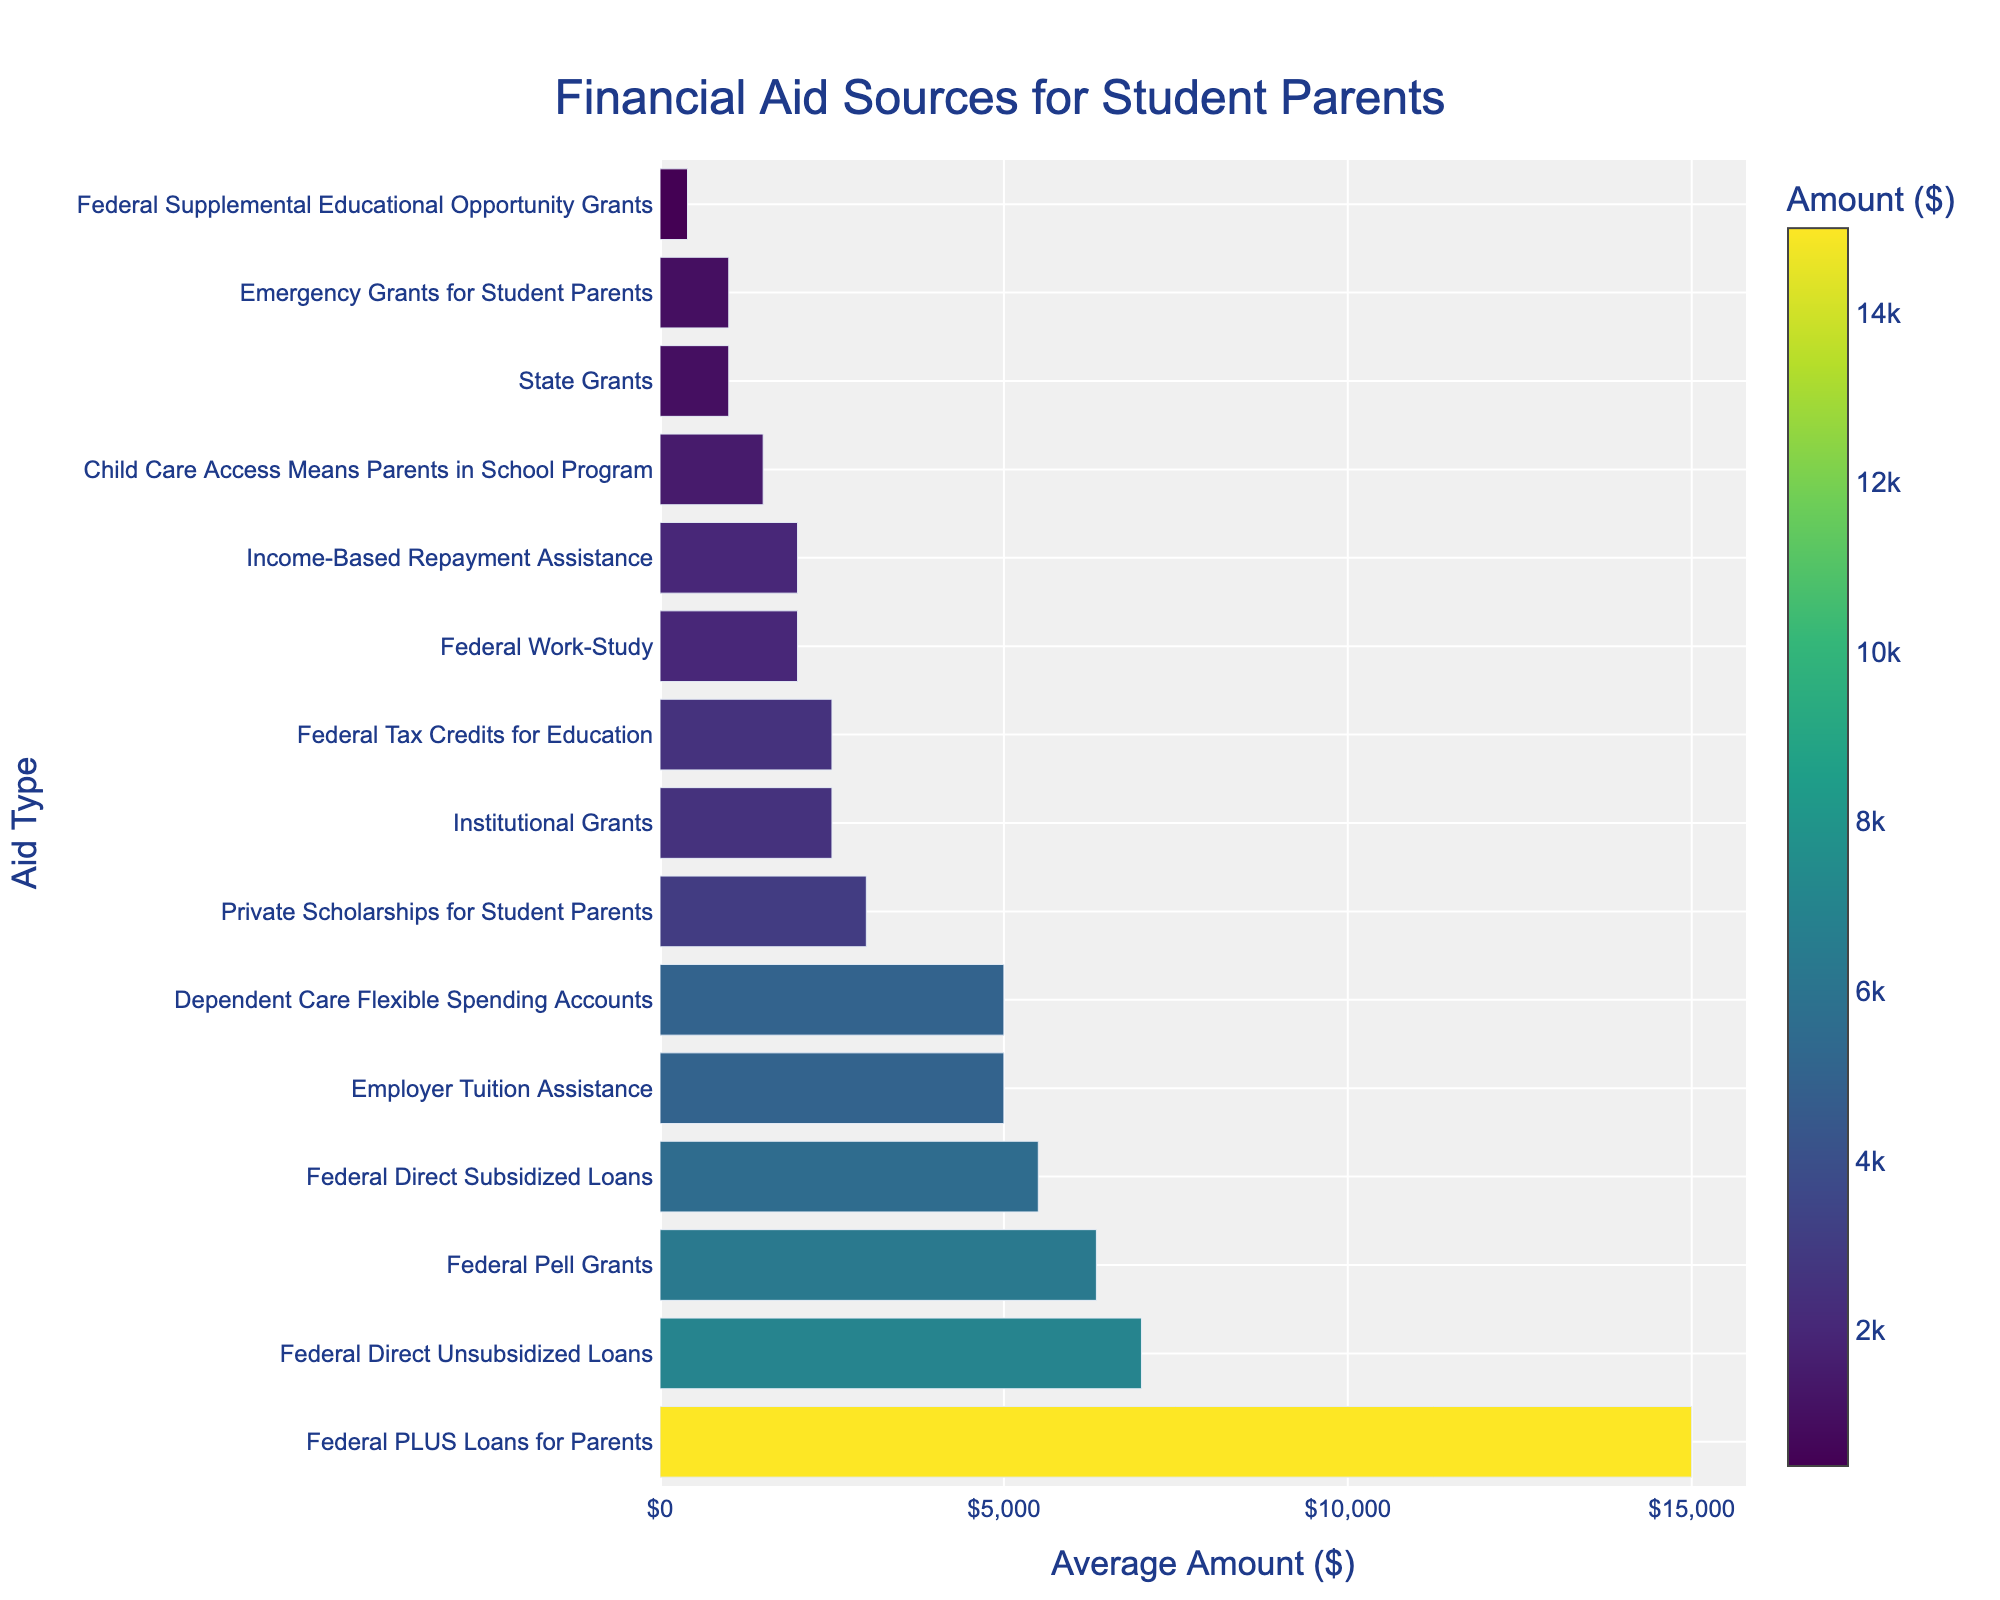What is the highest average amount of financial aid provided for student parents? The bar representing "Federal PLUS Loans for Parents" is the longest, indicating it has the highest average amount of financial aid.
Answer: $15,000 Which financial aid type has the lowest average amount? The bar for "Federal Supplemental Educational Opportunity Grants" is the shortest, indicating it has the lowest average amount.
Answer: $400 How much more on average does "Employer Tuition Assistance" provide compared to "Institutional Grants"? The average amount for "Employer Tuition Assistance" is $5,000 and for "Institutional Grants" is $2,500. The difference is $5,000 - $2,500.
Answer: $2,500 What is the total average amount of federal grants listed? Summing the average amounts for Federal Pell Grants ($6,345) and Federal Supplemental Educational Opportunity Grants ($400) gives $6,345 + $400.
Answer: $6,745 Compare the average amounts between "Federal Work-Study" and "Income-Based Repayment Assistance." Which one is higher and by how much? The average amount for "Federal Work-Study" is $2,000, while for "Income-Based Repayment Assistance" it's also $2,000. They are the same.
Answer: $0 What is the combined average amount of "State Grants" and "Emergency Grants for Student Parents"? The average amount for "State Grants" is $1,000 and for "Emergency Grants for Student Parents" is also $1,000. The combined amount is $1,000 + $1,000.
Answer: $2,000 Which financial aid source is closest in amount to "Private Scholarships for Student Parents"? "Private Scholarships for Student Parents" have an average amount of $3,000. "Federal Work-Study" and "Income-Based Repayment Assistance" both have an average amount of $2,000, which are $1,000 less. "Child Care Access Means Parents in School Program" has an average of $1,500, $1,500 less. "Federal Tax Credits for Education" and "Dependent Care Flexible Spending Accounts" both have an average amount of $2,500, which is $500 less.
Answer: Federal Tax Credits for Education, Dependent Care Flexible Spending Accounts Which has a higher average amount: "Federal Direct Unsubsidized Loans" or "Federal Direct Subsidized Loans"? "Federal Direct Unsubsidized Loans" have a higher average amount of $7,000 compared to "Federal Direct Subsidized Loans" which have an average amount of $5,500.
Answer: Federal Direct Unsubsidized Loans 